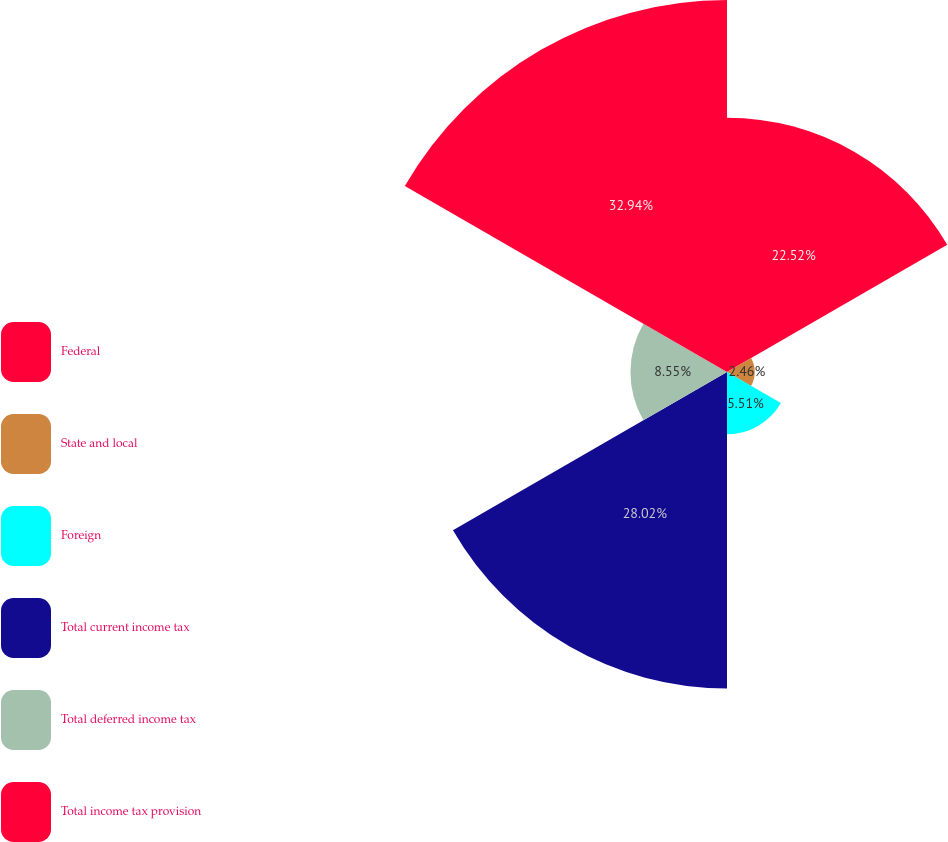Convert chart. <chart><loc_0><loc_0><loc_500><loc_500><pie_chart><fcel>Federal<fcel>State and local<fcel>Foreign<fcel>Total current income tax<fcel>Total deferred income tax<fcel>Total income tax provision<nl><fcel>22.52%<fcel>2.46%<fcel>5.51%<fcel>28.02%<fcel>8.55%<fcel>32.94%<nl></chart> 